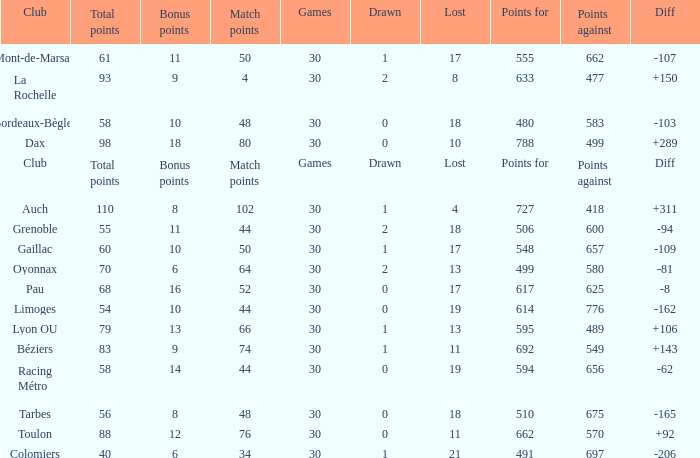What is the number of games for a club that has 34 match points? 30.0. 